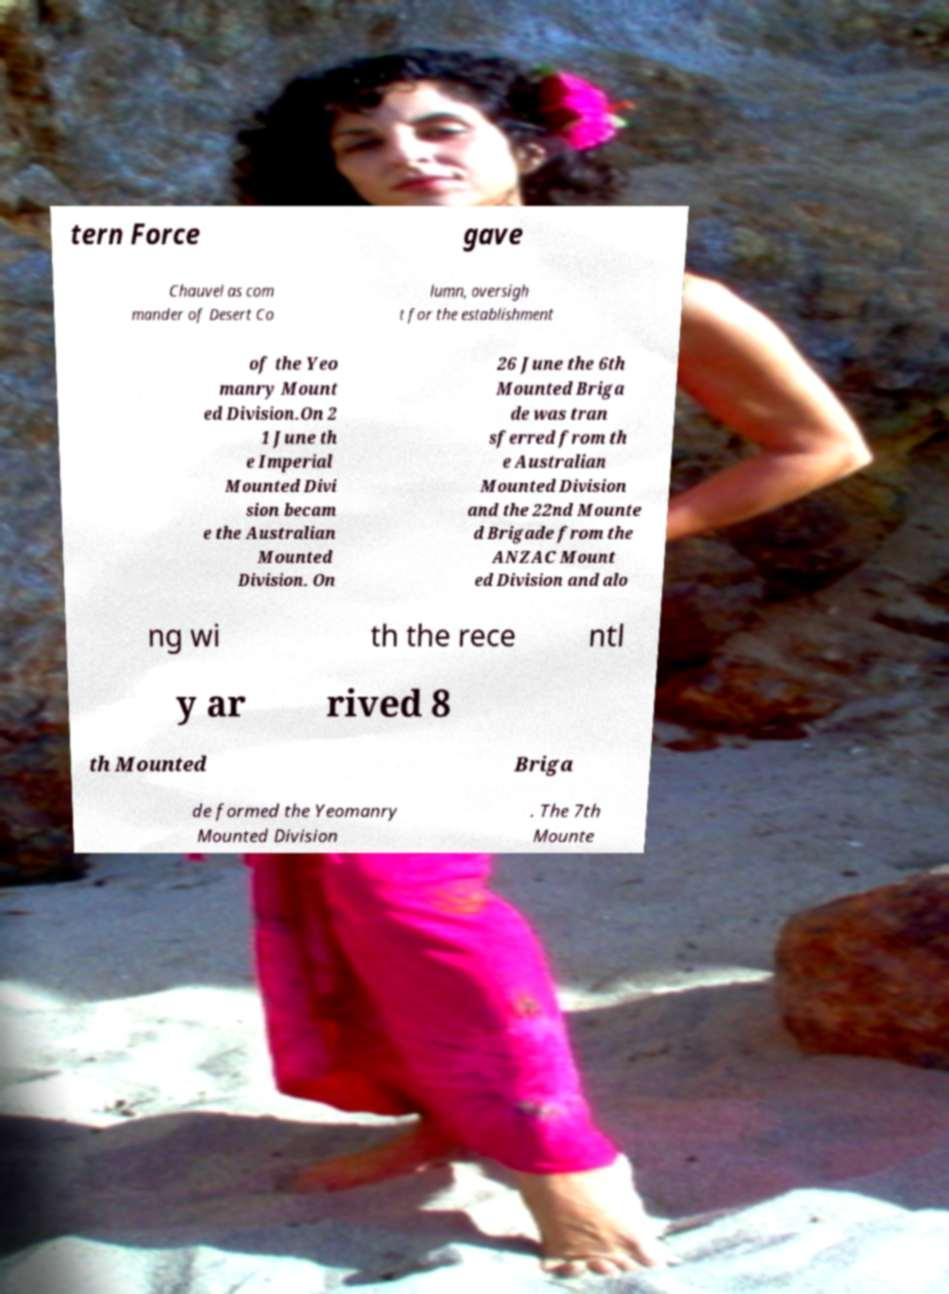For documentation purposes, I need the text within this image transcribed. Could you provide that? tern Force gave Chauvel as com mander of Desert Co lumn, oversigh t for the establishment of the Yeo manry Mount ed Division.On 2 1 June th e Imperial Mounted Divi sion becam e the Australian Mounted Division. On 26 June the 6th Mounted Briga de was tran sferred from th e Australian Mounted Division and the 22nd Mounte d Brigade from the ANZAC Mount ed Division and alo ng wi th the rece ntl y ar rived 8 th Mounted Briga de formed the Yeomanry Mounted Division . The 7th Mounte 